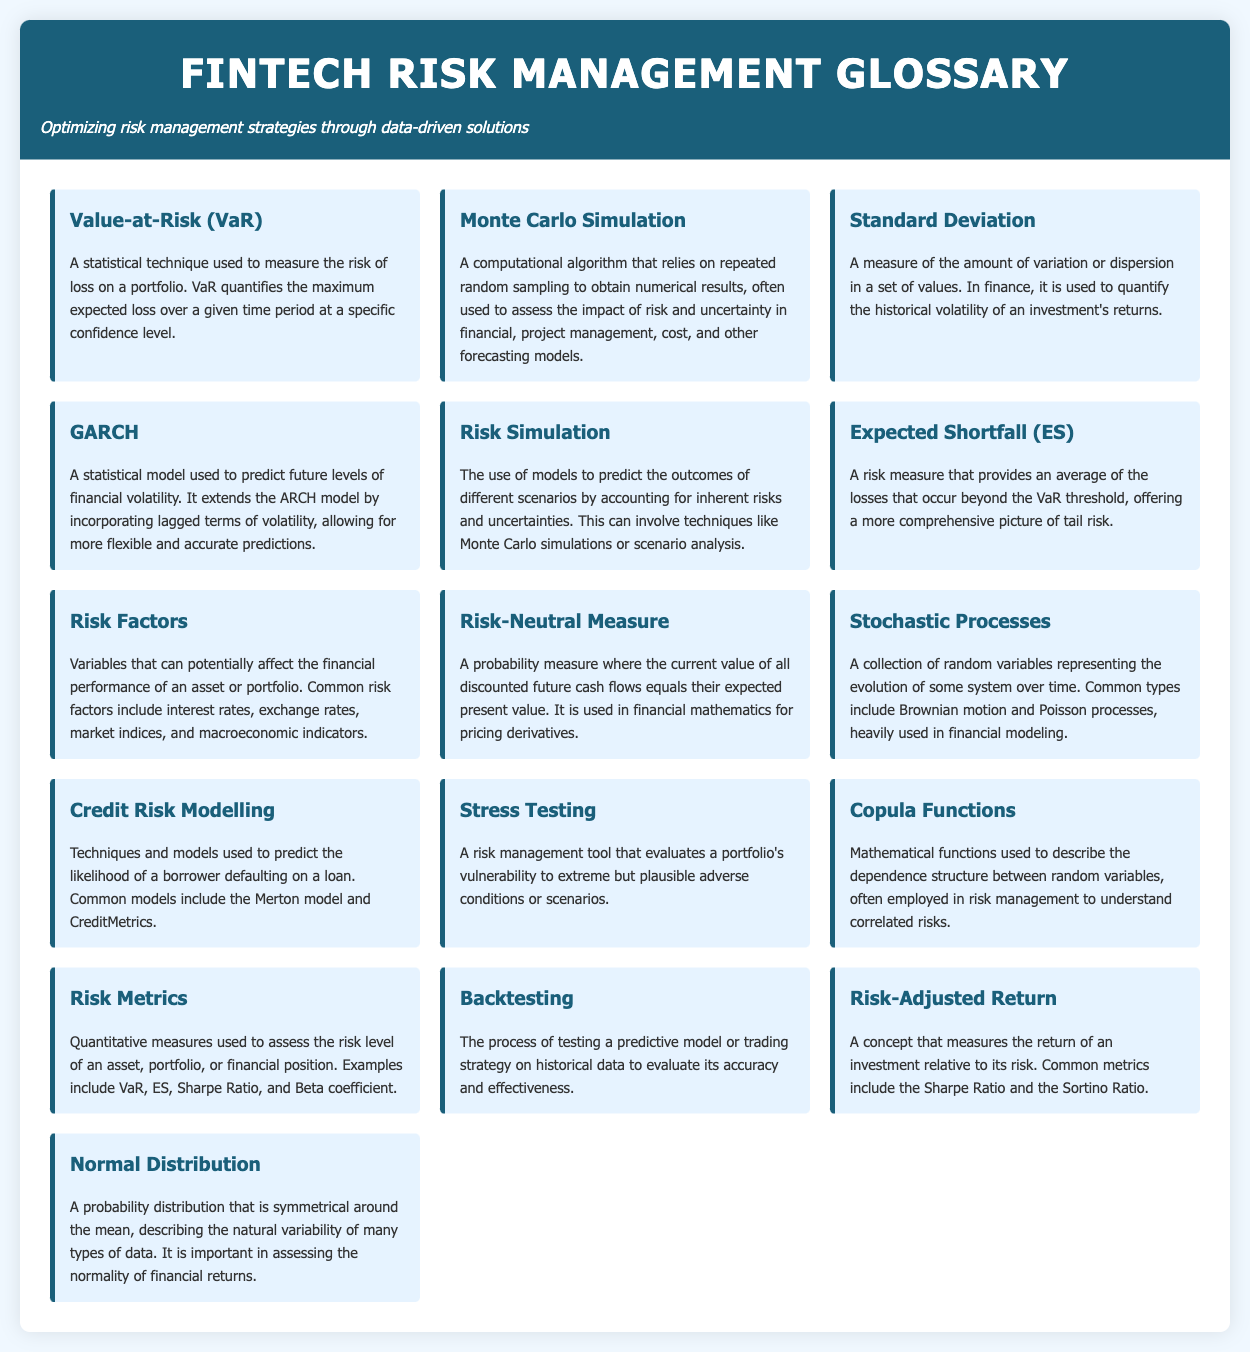what is Value-at-Risk (VaR)? Value-at-Risk (VaR) is defined as a statistical technique used to measure the risk of loss on a portfolio, quantifying the maximum expected loss over a given time period at a specific confidence level.
Answer: A statistical technique what does Monte Carlo Simulation rely on? Monte Carlo Simulation is described as a computational algorithm that relies on repeated random sampling to obtain numerical results.
Answer: Repeated random sampling what is the purpose of Expected Shortfall (ES)? Expected Shortfall (ES) provides an average of the losses that occur beyond the VaR threshold, offering a more comprehensive picture of tail risk.
Answer: Measure of tail risk what is GARCH used for? GARCH is a statistical model used to predict future levels of financial volatility, extending the ARCH model by incorporating lagged terms of volatility.
Answer: Predicting volatility what concept does Risk-Adjusted Return relate to? Risk-Adjusted Return measures the return of an investment relative to its risk, utilizing metrics like the Sharpe Ratio and Sortino Ratio.
Answer: Return relative to risk what type of measure is a Risk-Neutral Measure? A Risk-Neutral Measure represents a probability measure where the current value of all discounted future cash flows equals their expected present value.
Answer: Probability measure what is a common application of Copula Functions? Copula Functions are often employed in risk management to understand correlated risks among random variables.
Answer: Understanding correlated risks what is the definition of Backtesting? Backtesting is defined as the process of testing a predictive model or trading strategy on historical data to evaluate its accuracy and effectiveness.
Answer: Testing on historical data 